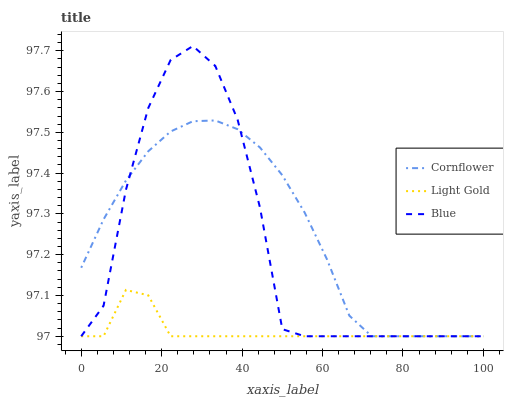Does Light Gold have the minimum area under the curve?
Answer yes or no. Yes. Does Cornflower have the maximum area under the curve?
Answer yes or no. Yes. Does Cornflower have the minimum area under the curve?
Answer yes or no. No. Does Light Gold have the maximum area under the curve?
Answer yes or no. No. Is Cornflower the smoothest?
Answer yes or no. Yes. Is Blue the roughest?
Answer yes or no. Yes. Is Light Gold the smoothest?
Answer yes or no. No. Is Light Gold the roughest?
Answer yes or no. No. Does Blue have the lowest value?
Answer yes or no. Yes. Does Blue have the highest value?
Answer yes or no. Yes. Does Cornflower have the highest value?
Answer yes or no. No. Does Blue intersect Cornflower?
Answer yes or no. Yes. Is Blue less than Cornflower?
Answer yes or no. No. Is Blue greater than Cornflower?
Answer yes or no. No. 